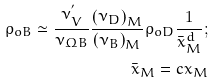<formula> <loc_0><loc_0><loc_500><loc_500>\rho _ { o B } \simeq \frac { \nu ^ { ^ { \prime } } _ { V } } { \nu _ { \Omega B } } \frac { \left ( \nu _ { D } \right ) _ { M } } { \left ( \nu _ { B } \right ) _ { M } } \rho _ { o D } \frac { 1 } { \bar { x } ^ { d } _ { M } } ; \\ \ \bar { x } _ { M } = c x _ { M }</formula> 